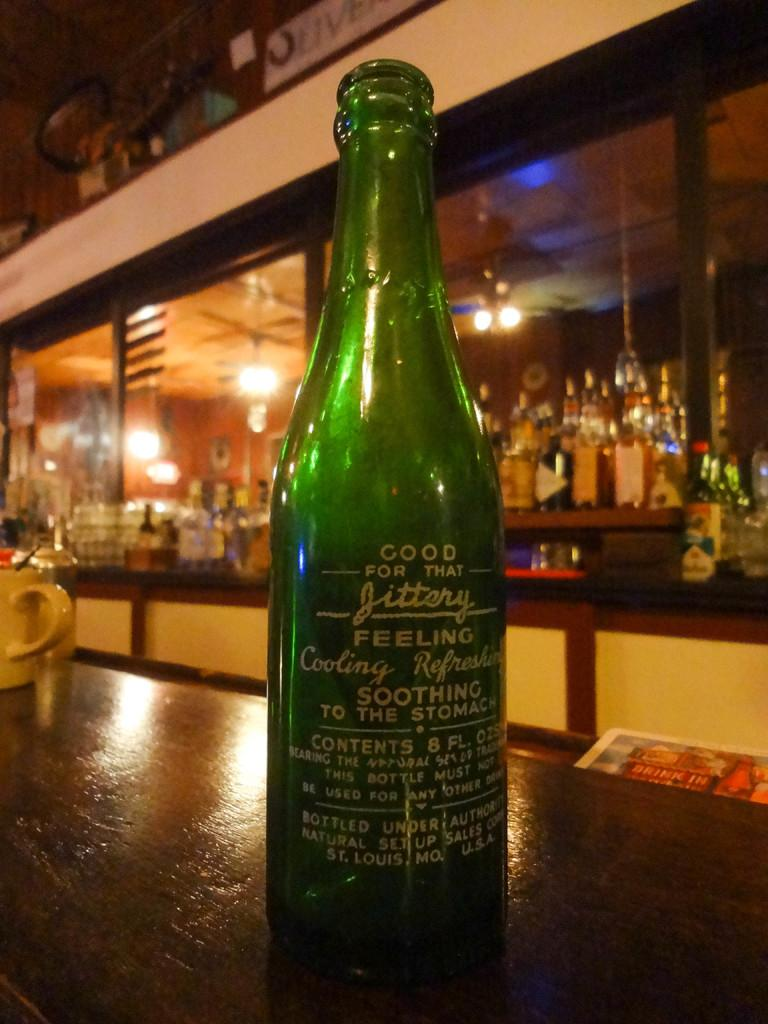<image>
Present a compact description of the photo's key features. A green bottle of Jittery on top of a bar counter. 